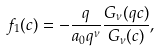Convert formula to latex. <formula><loc_0><loc_0><loc_500><loc_500>f _ { 1 } ( c ) = - \frac { q } { a _ { 0 } q ^ { \nu } } \frac { G _ { \nu } ( q c ) } { G _ { \nu } ( c ) } ,</formula> 